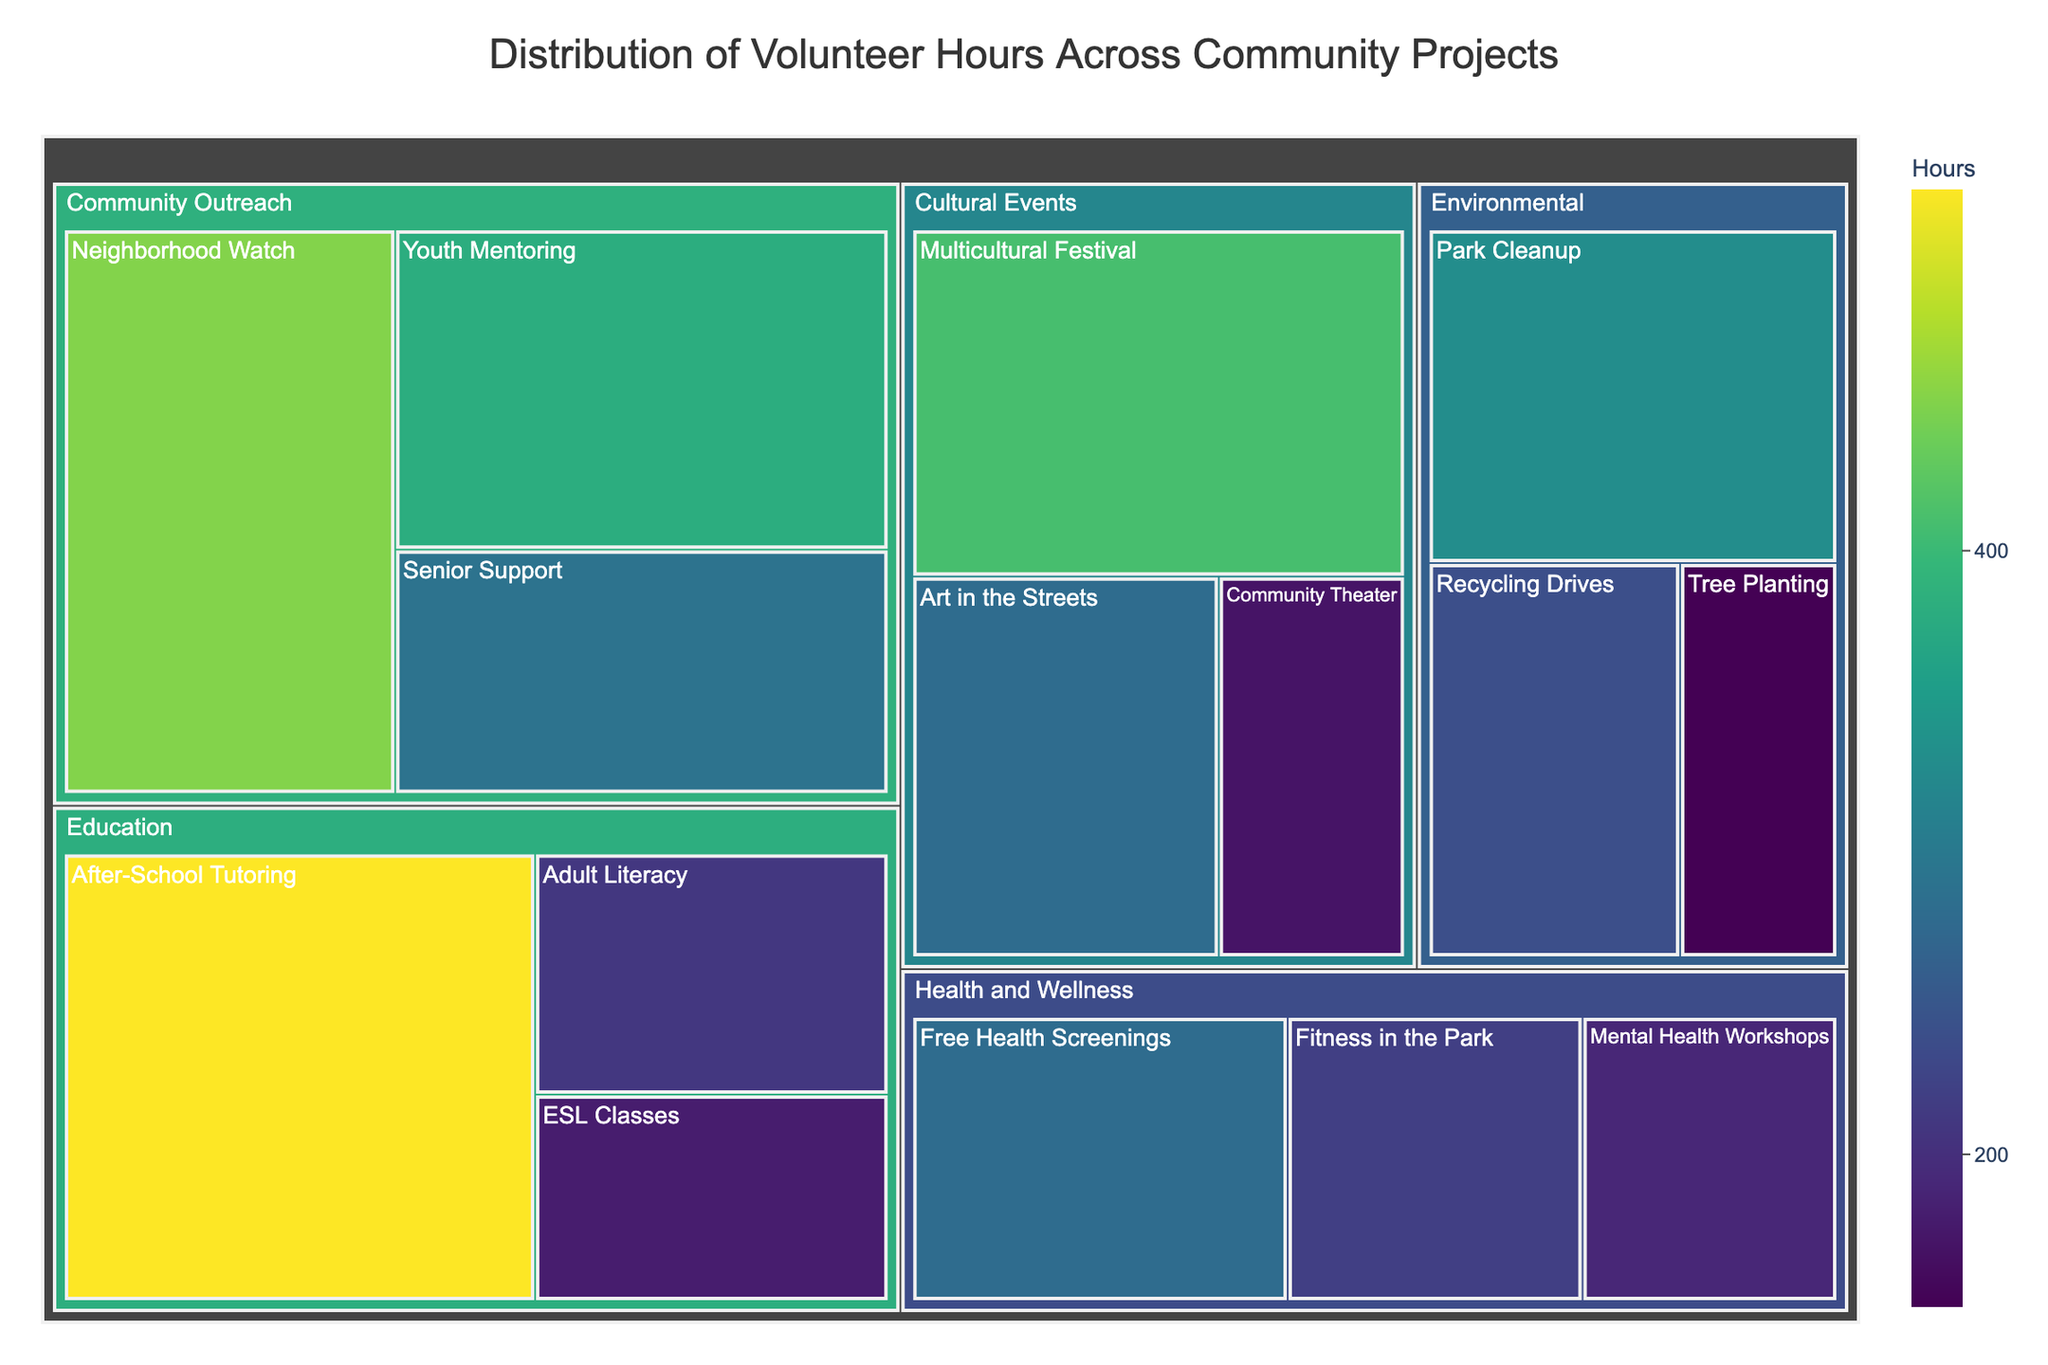What is the title of the Treemap? The title is displayed at the top center of the Treemap, and it provides an overview of what the visual represents.
Answer: Distribution of Volunteer Hours Across Community Projects How many hours were spent on Community Outreach projects altogether? To find this, sum the hours of the three subcategories under Community Outreach (Neighborhood Watch, Youth Mentoring, Senior Support): 450 + 380 + 290 = 1120 hours.
Answer: 1120 hours Which category has the largest total volunteer hours? By comparing the summed hours of each major category (Community Outreach, Education, Environmental, Health and Wellness, Cultural Events), Education has the highest total with 910 hours.
Answer: Education Which subcategory within Health and Wellness has the fewest volunteer hours? Within Health and Wellness, compare the hours of Free Health Screenings (280), Mental Health Workshops (190), and Fitness in the Park (220). The fewest hours are for Mental Health Workshops.
Answer: Mental Health Workshops What is the total number of volunteer hours spent on Environmental projects? Sum the hours of the three subcategories under Environmental: Park Cleanup (330), Recycling Drives (240), Tree Planting (150). The total is 330 + 240 + 150 = 720 hours.
Answer: 720 hours Are there more volunteer hours in Cultural Events or Health and Wellness? By how much? Sum the hours for Cultural Events (Multicultural Festival 410, Art in the Streets 280, Community Theater 170) and Health and Wellness (Free Health Screenings 280, Mental Health Workshops 190, Fitness in the Park 220). Cultural Events total: 410 + 280 + 170 = 860 hours. Health and Wellness total: 280 + 190 + 220 = 690 hours. Difference: 860 - 690 = 170 hours.
Answer: Cultural Events by 170 hours Which subcategory within Education has the most volunteer hours? Compare the hours of After-School Tutoring (520), Adult Literacy (210), and ESL Classes (180). The subcategory with the most hours is After-School Tutoring.
Answer: After-School Tutoring How many more hours were spent on Park Cleanup compared to Tree Planting? Subtract the hours of Tree Planting (150) from Park Cleanup (330): 330 - 150 = 180 hours.
Answer: 180 hours What color range represents the volunteer hours? The color scale used in the Treemap is 'Viridis', which ranges from a lighter to a darker green as the number of hours increases.
Answer: Light to dark green Which has more volunteer hours, Youth Mentoring or Free Health Screenings? Youth Mentoring has 380 hours, whereas Free Health Screenings has 280 hours. Hence, Youth Mentoring has more hours.
Answer: Youth Mentoring 